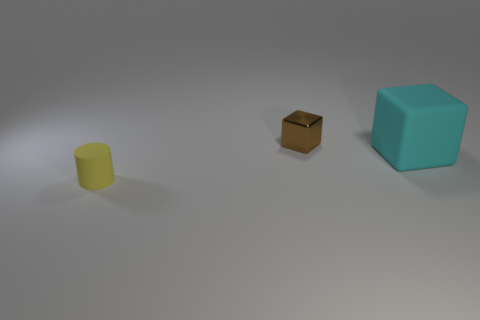Are there any other things that have the same shape as the yellow object?
Offer a terse response. No. Is the number of yellow cylinders behind the cyan block less than the number of big cyan cubes that are behind the yellow cylinder?
Provide a short and direct response. Yes. What is the object that is both in front of the metal thing and behind the tiny yellow matte thing made of?
Provide a short and direct response. Rubber. What is the shape of the object that is on the right side of the block behind the cyan cube?
Keep it short and to the point. Cube. Is the color of the metallic cube the same as the tiny cylinder?
Give a very brief answer. No. What number of blue objects are either small cubes or big cubes?
Offer a very short reply. 0. There is a cyan block; are there any yellow objects in front of it?
Give a very brief answer. Yes. How big is the cylinder?
Your answer should be compact. Small. There is a brown shiny thing that is the same shape as the cyan matte object; what is its size?
Make the answer very short. Small. How many big things are to the right of the small object right of the tiny cylinder?
Keep it short and to the point. 1. 